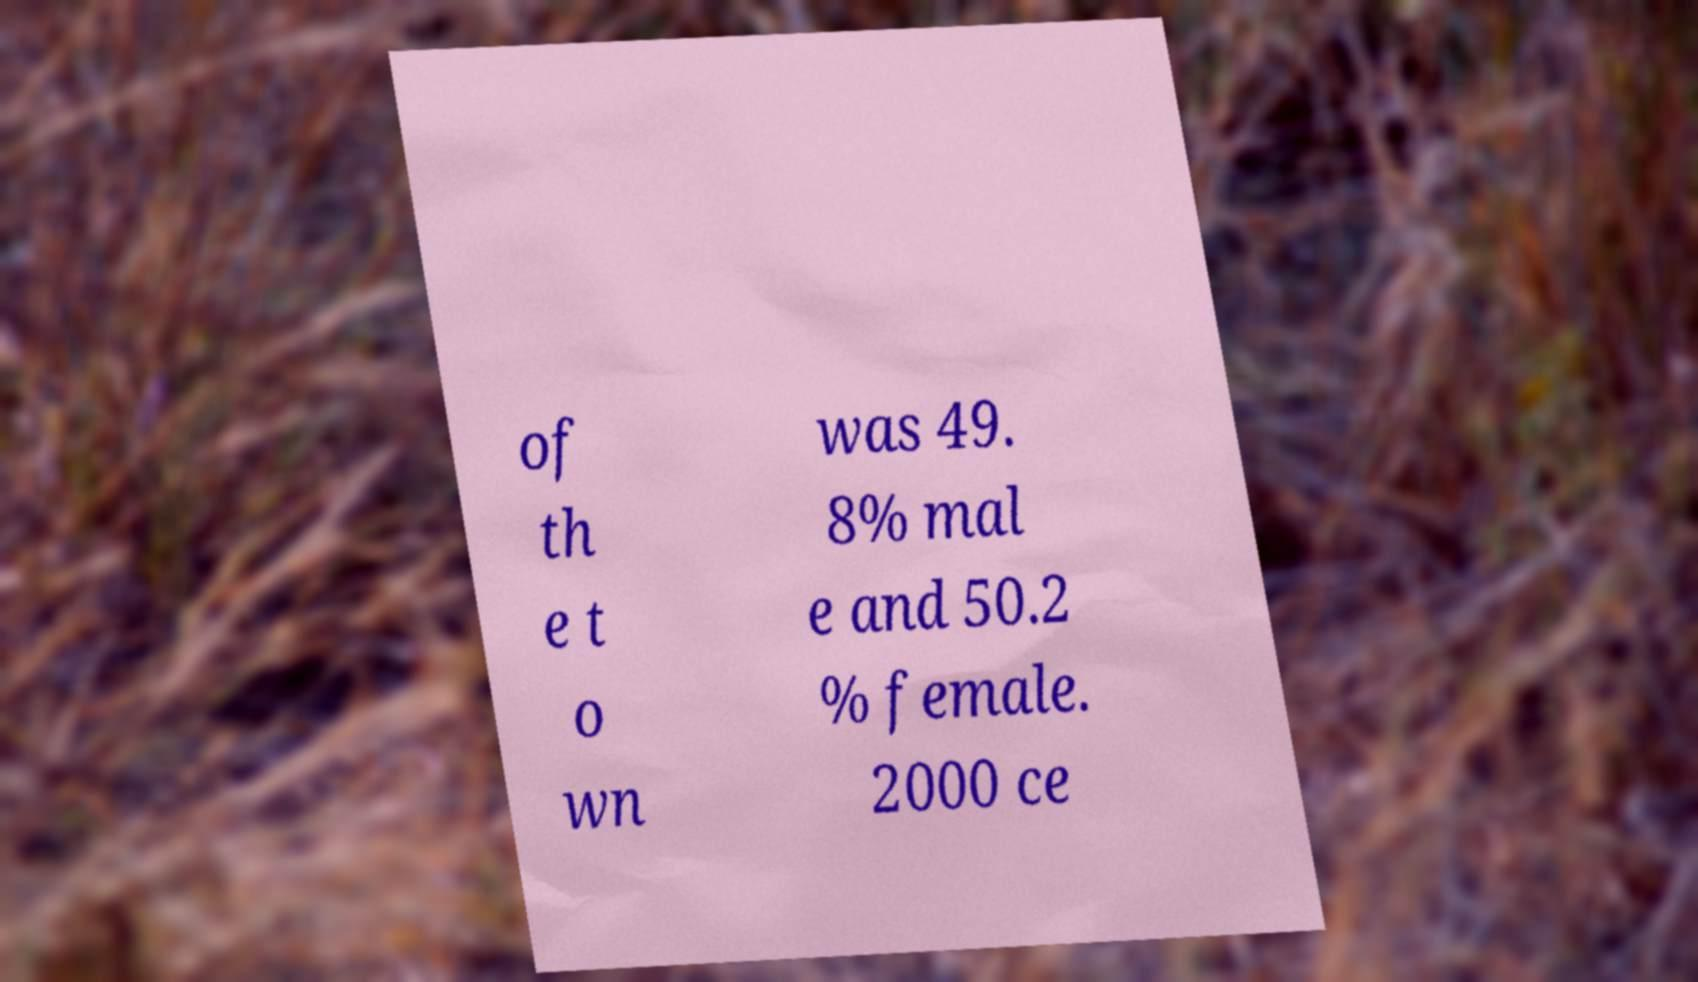I need the written content from this picture converted into text. Can you do that? of th e t o wn was 49. 8% mal e and 50.2 % female. 2000 ce 